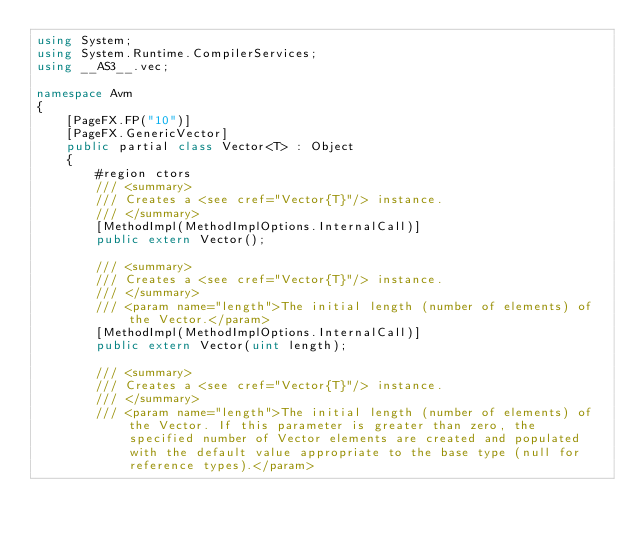<code> <loc_0><loc_0><loc_500><loc_500><_C#_>using System;
using System.Runtime.CompilerServices;
using __AS3__.vec;

namespace Avm
{
    [PageFX.FP("10")]
    [PageFX.GenericVector]
    public partial class Vector<T> : Object
    {
        #region ctors
        /// <summary>
        /// Creates a <see cref="Vector{T}"/> instance. 
        /// </summary>
        [MethodImpl(MethodImplOptions.InternalCall)]
        public extern Vector();

        /// <summary>
        /// Creates a <see cref="Vector{T}"/> instance. 
        /// </summary>
        /// <param name="length">The initial length (number of elements) of the Vector.</param>
        [MethodImpl(MethodImplOptions.InternalCall)]
        public extern Vector(uint length);

        /// <summary>
        /// Creates a <see cref="Vector{T}"/> instance. 
        /// </summary>
        /// <param name="length">The initial length (number of elements) of the Vector. If this parameter is greater than zero, the specified number of Vector elements are created and populated with the default value appropriate to the base type (null for reference types).</param></code> 